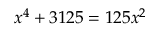<formula> <loc_0><loc_0><loc_500><loc_500>x ^ { 4 } + 3 1 2 5 = 1 2 5 x ^ { 2 }</formula> 